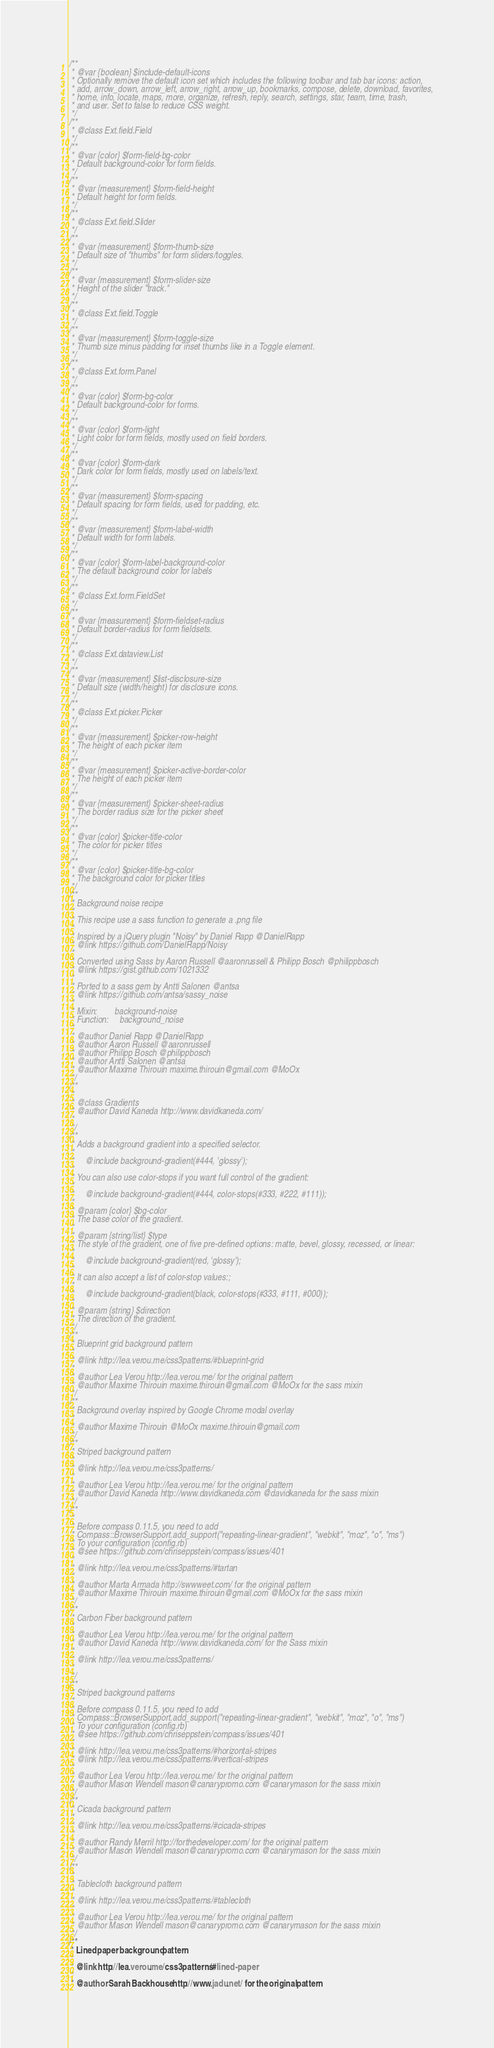Convert code to text. <code><loc_0><loc_0><loc_500><loc_500><_CSS_>/**
 * @var {boolean} $include-default-icons
 * Optionally remove the default icon set which includes the following toolbar and tab bar icons: action,
 * add, arrow_down, arrow_left, arrow_right, arrow_up, bookmarks, compose, delete, download, favorites,
 * home, info, locate, maps, more, organize, refresh, reply, search, settings, star, team, time, trash,
 * and user. Set to false to reduce CSS weight.
 */
/**
 * @class Ext.field.Field
 */
/**
 * @var {color} $form-field-bg-color
 * Default background-color for form fields.
 */
/**
 * @var {measurement} $form-field-height
 * Default height for form fields.
 */
/**
 * @class Ext.field.Slider
 */
/**
 * @var {measurement} $form-thumb-size
 * Default size of "thumbs" for form sliders/toggles.
 */
/**
 * @var {measurement} $form-slider-size
 * Height of the slider "track."
 */
/**
 * @class Ext.field.Toggle
 */
/**
 * @var {measurement} $form-toggle-size
 * Thumb size minus padding for inset thumbs like in a Toggle element.
 */
/**
 * @class Ext.form.Panel
 */
/**
 * @var {color} $form-bg-color
 * Default background-color for forms.
 */
/**
 * @var {color} $form-light
 * Light color for form fields, mostly used on field borders.
 */
/**
 * @var {color} $form-dark
 * Dark color for form fields, mostly used on labels/text.
 */
/**
 * @var {measurement} $form-spacing
 * Default spacing for form fields, used for padding, etc.
 */
/**
 * @var {measurement} $form-label-width
 * Default width for form labels.
 */
/**
 * @var {color} $form-label-background-color
 * The default background color for labels
 */
/**
 * @class Ext.form.FieldSet
 */
/**
 * @var {measurement} $form-fieldset-radius
 * Default border-radius for form fieldsets.
 */
/**
 * @class Ext.dataview.List
 */
/**
 * @var {measurement} $list-disclosure-size
 * Default size (width/height) for disclosure icons.
 */
/**
 * @class Ext.picker.Picker
 */
/**
 * @var {measurement} $picker-row-height
 * The height of each picker item
 */
/**
 * @var {measurement} $picker-active-border-color
 * The height of each picker item
 */
/**
 * @var {measurement} $picker-sheet-radius
 * The border radius size for the picker sheet
 */
/**
 * @var {color} $picker-title-color
 * The color for picker titles
 */
/**
 * @var {color} $picker-title-bg-color
 * The background color for picker titles
 */
/**
 * Background noise recipe
 * 
 * This recipe use a sass function to generate a .png file
 * 
 * Inspired by a jQuery plugin "Noisy" by Daniel Rapp @DanielRapp
 * @link https://github.com/DanielRapp/Noisy
 * 
 * Converted using Sass by Aaron Russell @aaronrussell & Philipp Bosch @philippbosch
 * @link https://gist.github.com/1021332
 * 
 * Ported to a sass gem by Antti Salonen @antsa
 * @link https://github.com/antsa/sassy_noise
 * 
 * Mixin:        background-noise
 * Function:     background_noise
 * 
 * @author Daniel Rapp @DanielRapp
 * @author Aaron Russell @aaronrussell
 * @author Philipp Bosch @philippbosch
 * @author Antti Salonen @antsa
 * @author Maxime Thirouin maxime.thirouin@gmail.com @MoOx
 */
/**
 *
 * @class Gradients
 * @author David Kaneda http://www.davidkaneda.com/
 *
 */
/**
 * Adds a background gradient into a specified selector.
 *
 *     @include background-gradient(#444, 'glossy');
 *
 * You can also use color-stops if you want full control of the gradient:
 *
 *     @include background-gradient(#444, color-stops(#333, #222, #111));
 *
 * @param {color} $bg-color
 * The base color of the gradient.
 *
 * @param {string/list} $type
 * The style of the gradient, one of five pre-defined options: matte, bevel, glossy, recessed, or linear:
 *
 *     @include background-gradient(red, 'glossy');
 *
 * It can also accept a list of color-stop values:;
 *
 *     @include background-gradient(black, color-stops(#333, #111, #000));
 *
 * @param {string} $direction
 * The direction of the gradient.
 */
/**
 * Blueprint grid background pattern
 * 
 * @link http://lea.verou.me/css3patterns/#blueprint-grid
 *
 * @author Lea Verou http://lea.verou.me/ for the original pattern
 * @author Maxime Thirouin maxime.thirouin@gmail.com @MoOx for the sass mixin
 */
/**
 * Background overlay inspired by Google Chrome modal overlay
 * 
 * @author Maxime Thirouin @MoOx maxime.thirouin@gmail.com
 */
/**
 * Striped background pattern
 * 
 * @link http://lea.verou.me/css3patterns/
 *
 * @author Lea Verou http://lea.verou.me/ for the original pattern
 * @author David Kaneda http://www.davidkaneda.com @davidkaneda for the sass mixin
 */
/**
 *
 * Before compass 0.11.5, you need to add
 * Compass::BrowserSupport.add_support("repeating-linear-gradient", "webkit", "moz", "o", "ms")
 * To your configuration (config.rb)
 * @see https://github.com/chriseppstein/compass/issues/401
 *
 * @link http://lea.verou.me/css3patterns/#tartan
 *
 * @author Marta Armada http://swwweet.com/ for the original pattern
 * @author Maxime Thirouin maxime.thirouin@gmail.com @MoOx for the sass mixin
 */
/**
 * Carbon Fiber background pattern
 *
 * @author Lea Verou http://lea.verou.me/ for the original pattern
 * @author David Kaneda http://www.davidkaneda.com/ for the Sass mixin
 *
 * @link http://lea.verou.me/css3patterns/
 *
 */
/**
 * Striped background patterns
 *
 * Before compass 0.11.5, you need to add
 * Compass::BrowserSupport.add_support("repeating-linear-gradient", "webkit", "moz", "o", "ms")
 * To your configuration (config.rb)
 * @see https://github.com/chriseppstein/compass/issues/401
 *
 * @link http://lea.verou.me/css3patterns/#horizontal-stripes
 * @link http://lea.verou.me/css3patterns/#vertical-stripes
 *
 * @author Lea Verou http://lea.verou.me/ for the original pattern
 * @author Mason Wendell mason@canarypromo.com @canarymason for the sass mixin
 */
/**
 * Cicada background pattern
 *
 * @link http://lea.verou.me/css3patterns/#cicada-stripes
 *
 * @author Randy Merril http://forthedeveloper.com/ for the original pattern
 * @author Mason Wendell mason@canarypromo.com @canarymason for the sass mixin
 */
/**
 *
 * Tablecloth background pattern
 *
 * @link http://lea.verou.me/css3patterns/#tablecloth
 *
 * @author Lea Verou http://lea.verou.me/ for the original pattern
 * @author Mason Wendell mason@canarypromo.com @canarymason for the sass mixin
 */
/**
 * Lined paper background pattern
 *
 * @link http://lea.verou.me/css3patterns/#lined-paper
 *
 * @author Sarah Backhouse http://www.jadu.net/ for the original pattern</code> 